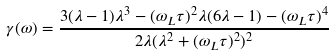Convert formula to latex. <formula><loc_0><loc_0><loc_500><loc_500>\gamma ( \omega ) = \frac { 3 ( \lambda - 1 ) \lambda ^ { 3 } - ( \omega _ { L } \tau ) ^ { 2 } \lambda ( 6 \lambda - 1 ) - ( \omega _ { L } \tau ) ^ { 4 } } { 2 \lambda ( \lambda ^ { 2 } + ( \omega _ { L } \tau ) ^ { 2 } ) ^ { 2 } }</formula> 